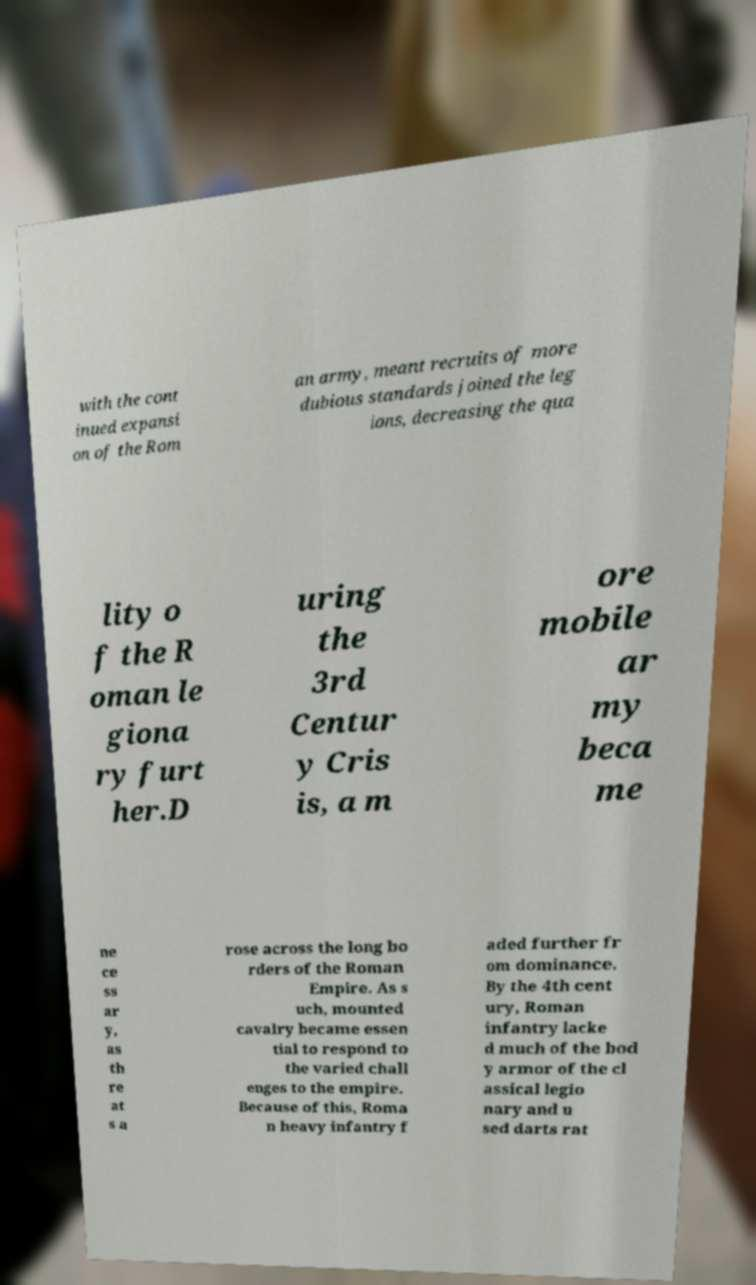Could you extract and type out the text from this image? with the cont inued expansi on of the Rom an army, meant recruits of more dubious standards joined the leg ions, decreasing the qua lity o f the R oman le giona ry furt her.D uring the 3rd Centur y Cris is, a m ore mobile ar my beca me ne ce ss ar y, as th re at s a rose across the long bo rders of the Roman Empire. As s uch, mounted cavalry became essen tial to respond to the varied chall enges to the empire. Because of this, Roma n heavy infantry f aded further fr om dominance. By the 4th cent ury, Roman infantry lacke d much of the bod y armor of the cl assical legio nary and u sed darts rat 